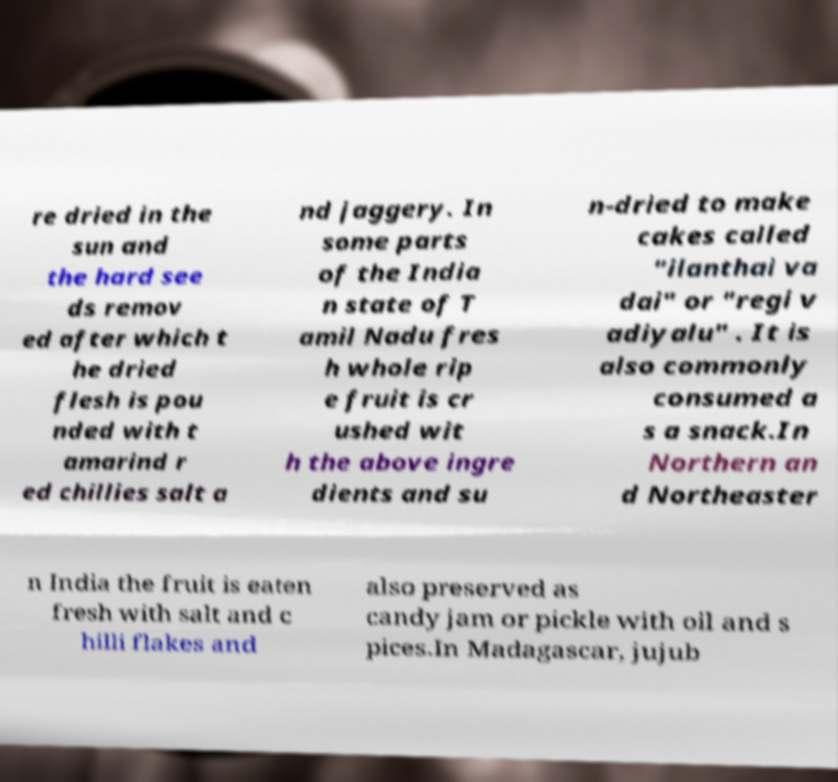For documentation purposes, I need the text within this image transcribed. Could you provide that? re dried in the sun and the hard see ds remov ed after which t he dried flesh is pou nded with t amarind r ed chillies salt a nd jaggery. In some parts of the India n state of T amil Nadu fres h whole rip e fruit is cr ushed wit h the above ingre dients and su n-dried to make cakes called "ilanthai va dai" or "regi v adiyalu" . It is also commonly consumed a s a snack.In Northern an d Northeaster n India the fruit is eaten fresh with salt and c hilli flakes and also preserved as candy jam or pickle with oil and s pices.In Madagascar, jujub 